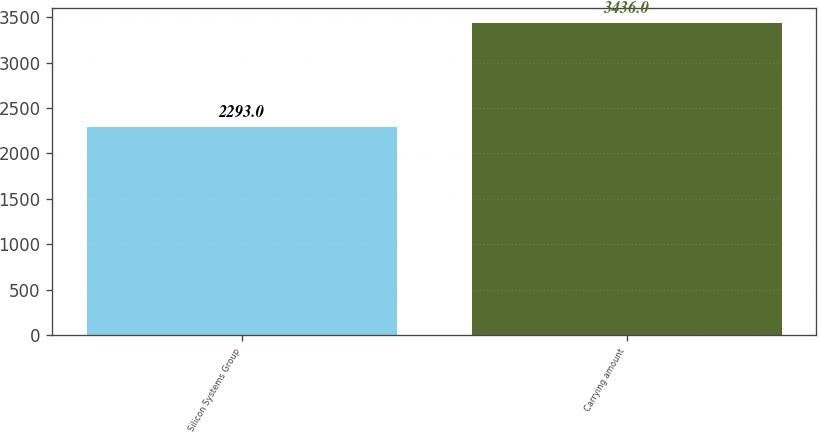<chart> <loc_0><loc_0><loc_500><loc_500><bar_chart><fcel>Silicon Systems Group<fcel>Carrying amount<nl><fcel>2293<fcel>3436<nl></chart> 